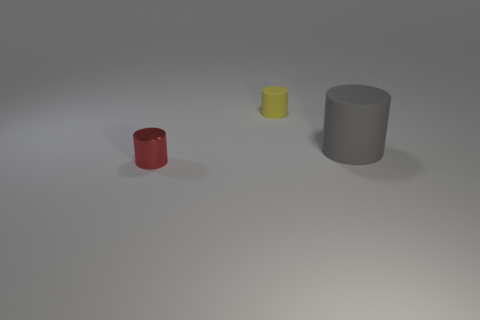Add 2 small purple rubber spheres. How many objects exist? 5 Subtract 0 cyan cubes. How many objects are left? 3 Subtract all tiny blue spheres. Subtract all gray rubber objects. How many objects are left? 2 Add 1 tiny cylinders. How many tiny cylinders are left? 3 Add 3 cyan spheres. How many cyan spheres exist? 3 